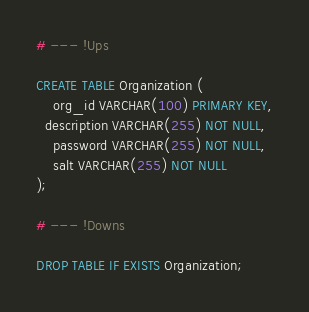<code> <loc_0><loc_0><loc_500><loc_500><_SQL_># --- !Ups

CREATE TABLE Organization (
	org_id VARCHAR(100) PRIMARY KEY,
  description VARCHAR(255) NOT NULL,
	password VARCHAR(255) NOT NULL,
	salt VARCHAR(255) NOT NULL
);

# --- !Downs

DROP TABLE IF EXISTS Organization;
</code> 